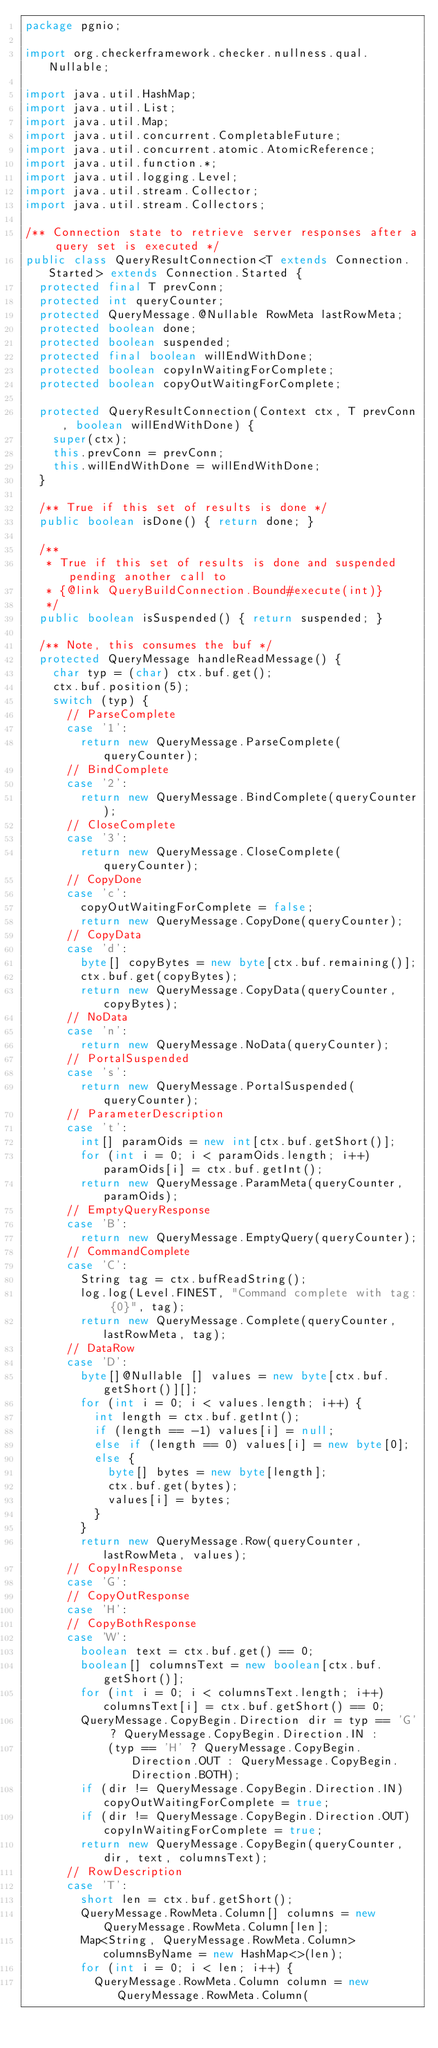<code> <loc_0><loc_0><loc_500><loc_500><_Java_>package pgnio;

import org.checkerframework.checker.nullness.qual.Nullable;

import java.util.HashMap;
import java.util.List;
import java.util.Map;
import java.util.concurrent.CompletableFuture;
import java.util.concurrent.atomic.AtomicReference;
import java.util.function.*;
import java.util.logging.Level;
import java.util.stream.Collector;
import java.util.stream.Collectors;

/** Connection state to retrieve server responses after a query set is executed */
public class QueryResultConnection<T extends Connection.Started> extends Connection.Started {
  protected final T prevConn;
  protected int queryCounter;
  protected QueryMessage.@Nullable RowMeta lastRowMeta;
  protected boolean done;
  protected boolean suspended;
  protected final boolean willEndWithDone;
  protected boolean copyInWaitingForComplete;
  protected boolean copyOutWaitingForComplete;

  protected QueryResultConnection(Context ctx, T prevConn, boolean willEndWithDone) {
    super(ctx);
    this.prevConn = prevConn;
    this.willEndWithDone = willEndWithDone;
  }

  /** True if this set of results is done */
  public boolean isDone() { return done; }

  /**
   * True if this set of results is done and suspended pending another call to
   * {@link QueryBuildConnection.Bound#execute(int)}
   */
  public boolean isSuspended() { return suspended; }

  /** Note, this consumes the buf */
  protected QueryMessage handleReadMessage() {
    char typ = (char) ctx.buf.get();
    ctx.buf.position(5);
    switch (typ) {
      // ParseComplete
      case '1':
        return new QueryMessage.ParseComplete(queryCounter);
      // BindComplete
      case '2':
        return new QueryMessage.BindComplete(queryCounter);
      // CloseComplete
      case '3':
        return new QueryMessage.CloseComplete(queryCounter);
      // CopyDone
      case 'c':
        copyOutWaitingForComplete = false;
        return new QueryMessage.CopyDone(queryCounter);
      // CopyData
      case 'd':
        byte[] copyBytes = new byte[ctx.buf.remaining()];
        ctx.buf.get(copyBytes);
        return new QueryMessage.CopyData(queryCounter, copyBytes);
      // NoData
      case 'n':
        return new QueryMessage.NoData(queryCounter);
      // PortalSuspended
      case 's':
        return new QueryMessage.PortalSuspended(queryCounter);
      // ParameterDescription
      case 't':
        int[] paramOids = new int[ctx.buf.getShort()];
        for (int i = 0; i < paramOids.length; i++) paramOids[i] = ctx.buf.getInt();
        return new QueryMessage.ParamMeta(queryCounter, paramOids);
      // EmptyQueryResponse
      case 'B':
        return new QueryMessage.EmptyQuery(queryCounter);
      // CommandComplete
      case 'C':
        String tag = ctx.bufReadString();
        log.log(Level.FINEST, "Command complete with tag: {0}", tag);
        return new QueryMessage.Complete(queryCounter, lastRowMeta, tag);
      // DataRow
      case 'D':
        byte[]@Nullable [] values = new byte[ctx.buf.getShort()][];
        for (int i = 0; i < values.length; i++) {
          int length = ctx.buf.getInt();
          if (length == -1) values[i] = null;
          else if (length == 0) values[i] = new byte[0];
          else {
            byte[] bytes = new byte[length];
            ctx.buf.get(bytes);
            values[i] = bytes;
          }
        }
        return new QueryMessage.Row(queryCounter, lastRowMeta, values);
      // CopyInResponse
      case 'G':
      // CopyOutResponse
      case 'H':
      // CopyBothResponse
      case 'W':
        boolean text = ctx.buf.get() == 0;
        boolean[] columnsText = new boolean[ctx.buf.getShort()];
        for (int i = 0; i < columnsText.length; i++) columnsText[i] = ctx.buf.getShort() == 0;
        QueryMessage.CopyBegin.Direction dir = typ == 'G' ? QueryMessage.CopyBegin.Direction.IN :
            (typ == 'H' ? QueryMessage.CopyBegin.Direction.OUT : QueryMessage.CopyBegin.Direction.BOTH);
        if (dir != QueryMessage.CopyBegin.Direction.IN) copyOutWaitingForComplete = true;
        if (dir != QueryMessage.CopyBegin.Direction.OUT) copyInWaitingForComplete = true;
        return new QueryMessage.CopyBegin(queryCounter, dir, text, columnsText);
      // RowDescription
      case 'T':
        short len = ctx.buf.getShort();
        QueryMessage.RowMeta.Column[] columns = new QueryMessage.RowMeta.Column[len];
        Map<String, QueryMessage.RowMeta.Column> columnsByName = new HashMap<>(len);
        for (int i = 0; i < len; i++) {
          QueryMessage.RowMeta.Column column = new QueryMessage.RowMeta.Column(</code> 